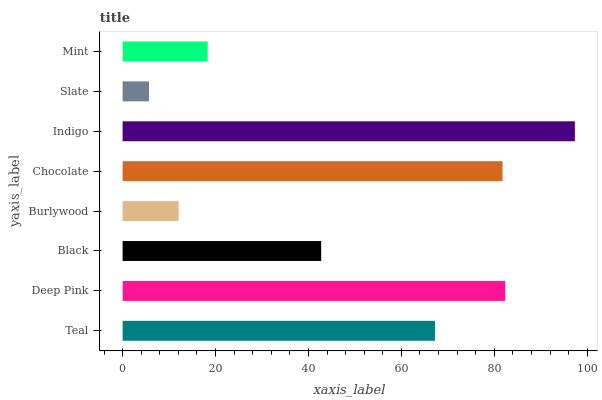Is Slate the minimum?
Answer yes or no. Yes. Is Indigo the maximum?
Answer yes or no. Yes. Is Deep Pink the minimum?
Answer yes or no. No. Is Deep Pink the maximum?
Answer yes or no. No. Is Deep Pink greater than Teal?
Answer yes or no. Yes. Is Teal less than Deep Pink?
Answer yes or no. Yes. Is Teal greater than Deep Pink?
Answer yes or no. No. Is Deep Pink less than Teal?
Answer yes or no. No. Is Teal the high median?
Answer yes or no. Yes. Is Black the low median?
Answer yes or no. Yes. Is Indigo the high median?
Answer yes or no. No. Is Mint the low median?
Answer yes or no. No. 